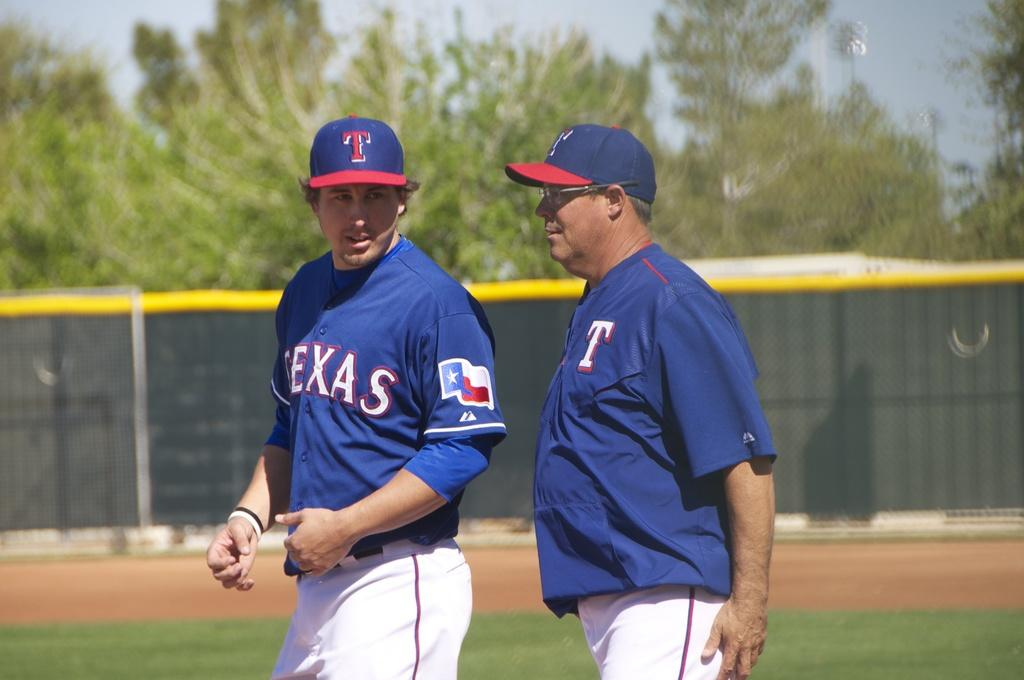<image>
Render a clear and concise summary of the photo. the name Texas that is on a jersey 